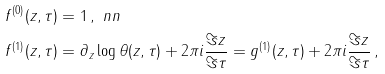Convert formula to latex. <formula><loc_0><loc_0><loc_500><loc_500>f ^ { ( 0 ) } ( z , \tau ) & = 1 \, , \ n n \\ f ^ { ( 1 ) } ( z , \tau ) & = \partial _ { z } \log \theta ( z , \tau ) + 2 \pi i \frac { \Im z } { \Im \tau } = g ^ { ( 1 ) } ( z , \tau ) + 2 \pi i \frac { \Im z } { \Im \tau } \, ,</formula> 